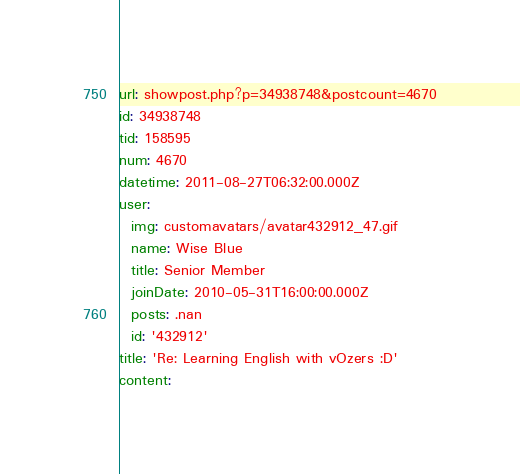<code> <loc_0><loc_0><loc_500><loc_500><_YAML_>url: showpost.php?p=34938748&postcount=4670
id: 34938748
tid: 158595
num: 4670
datetime: 2011-08-27T06:32:00.000Z
user:
  img: customavatars/avatar432912_47.gif
  name: Wise Blue
  title: Senior Member
  joinDate: 2010-05-31T16:00:00.000Z
  posts: .nan
  id: '432912'
title: 'Re: Learning English with vOzers :D'
content:</code> 